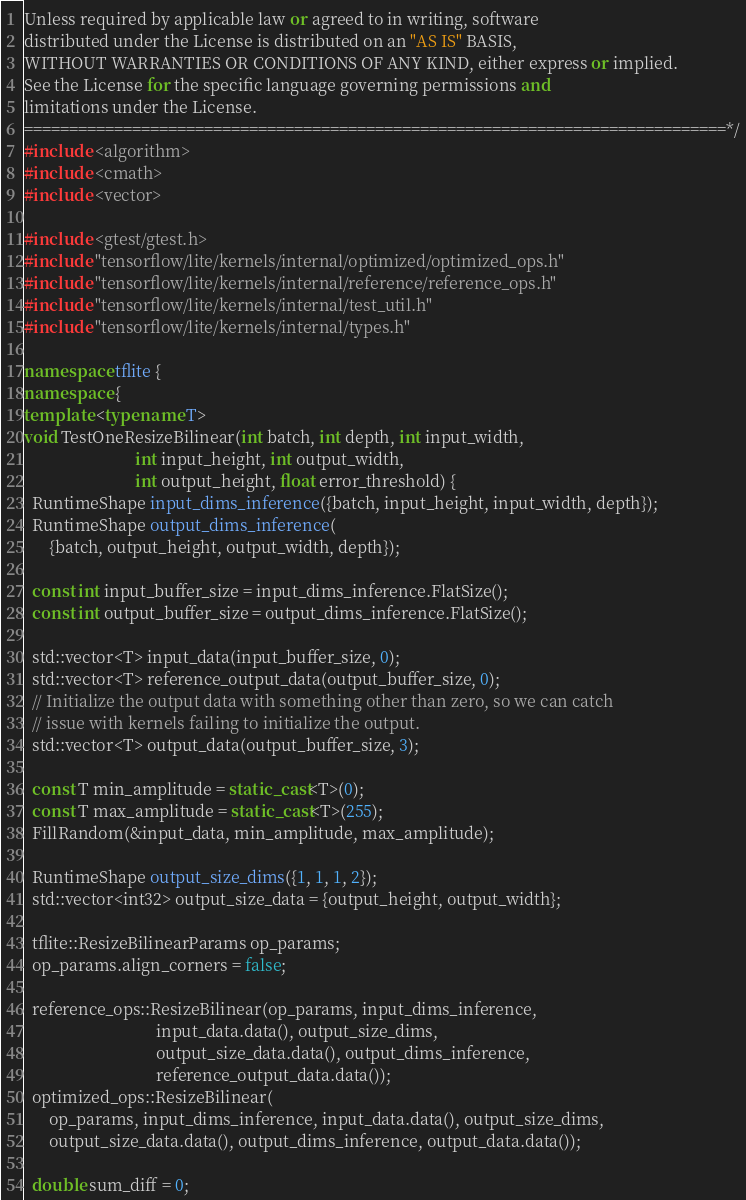<code> <loc_0><loc_0><loc_500><loc_500><_C++_>
Unless required by applicable law or agreed to in writing, software
distributed under the License is distributed on an "AS IS" BASIS,
WITHOUT WARRANTIES OR CONDITIONS OF ANY KIND, either express or implied.
See the License for the specific language governing permissions and
limitations under the License.
==============================================================================*/
#include <algorithm>
#include <cmath>
#include <vector>

#include <gtest/gtest.h>
#include "tensorflow/lite/kernels/internal/optimized/optimized_ops.h"
#include "tensorflow/lite/kernels/internal/reference/reference_ops.h"
#include "tensorflow/lite/kernels/internal/test_util.h"
#include "tensorflow/lite/kernels/internal/types.h"

namespace tflite {
namespace {
template <typename T>
void TestOneResizeBilinear(int batch, int depth, int input_width,
                           int input_height, int output_width,
                           int output_height, float error_threshold) {
  RuntimeShape input_dims_inference({batch, input_height, input_width, depth});
  RuntimeShape output_dims_inference(
      {batch, output_height, output_width, depth});

  const int input_buffer_size = input_dims_inference.FlatSize();
  const int output_buffer_size = output_dims_inference.FlatSize();

  std::vector<T> input_data(input_buffer_size, 0);
  std::vector<T> reference_output_data(output_buffer_size, 0);
  // Initialize the output data with something other than zero, so we can catch
  // issue with kernels failing to initialize the output.
  std::vector<T> output_data(output_buffer_size, 3);

  const T min_amplitude = static_cast<T>(0);
  const T max_amplitude = static_cast<T>(255);
  FillRandom(&input_data, min_amplitude, max_amplitude);

  RuntimeShape output_size_dims({1, 1, 1, 2});
  std::vector<int32> output_size_data = {output_height, output_width};

  tflite::ResizeBilinearParams op_params;
  op_params.align_corners = false;

  reference_ops::ResizeBilinear(op_params, input_dims_inference,
                                input_data.data(), output_size_dims,
                                output_size_data.data(), output_dims_inference,
                                reference_output_data.data());
  optimized_ops::ResizeBilinear(
      op_params, input_dims_inference, input_data.data(), output_size_dims,
      output_size_data.data(), output_dims_inference, output_data.data());

  double sum_diff = 0;</code> 